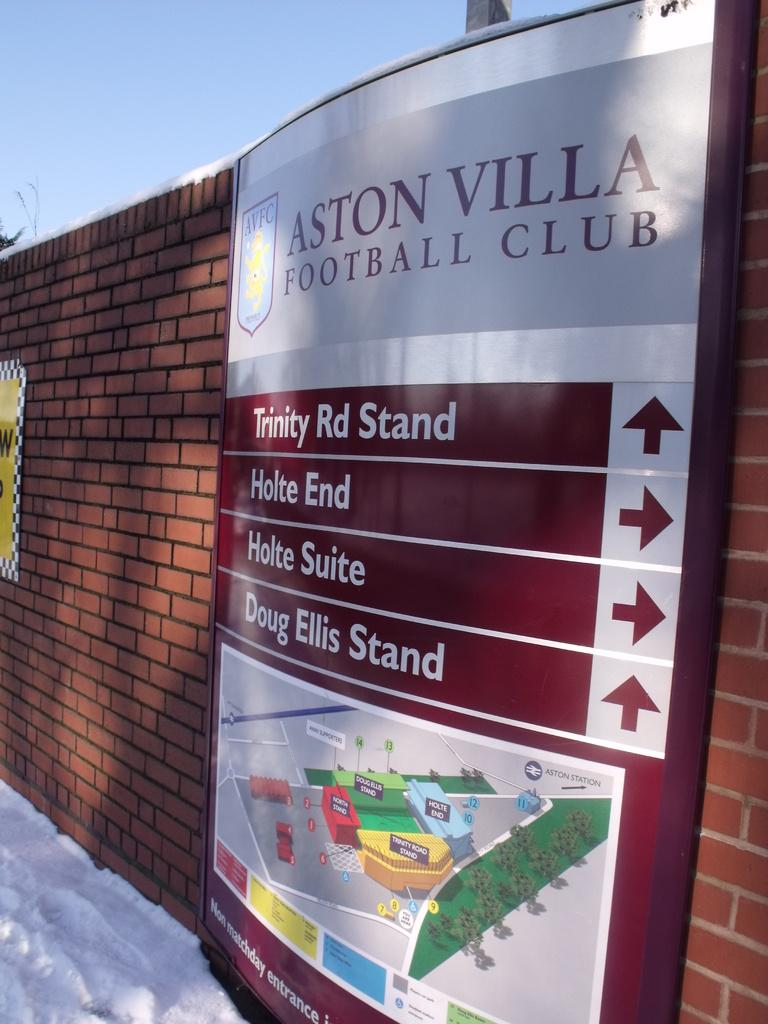<image>
Provide a brief description of the given image. A campus map of the Aston Villa Football Club shows both a picture and arrows pointing to different directions. 